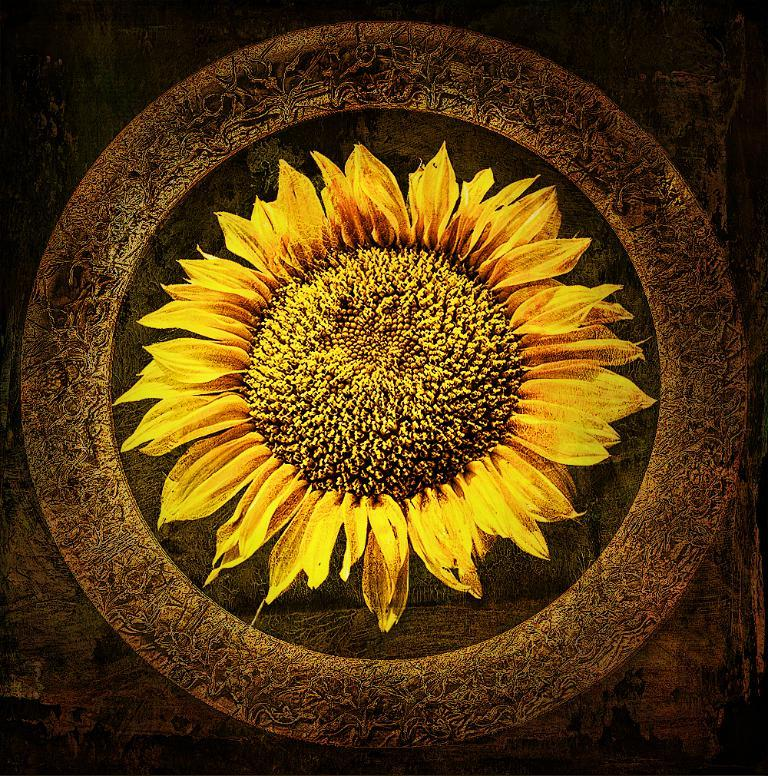What is the main subject of the image? The main subject of the image is a picture of a sunflower. What else can be seen in the image besides the sunflower? There is a design on a platform in the image. How much blood is visible on the sunflower in the image? There is no blood visible on the sunflower in the image, as it is a picture of a sunflower and not a living organism. 